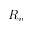<formula> <loc_0><loc_0><loc_500><loc_500>R _ { v }</formula> 